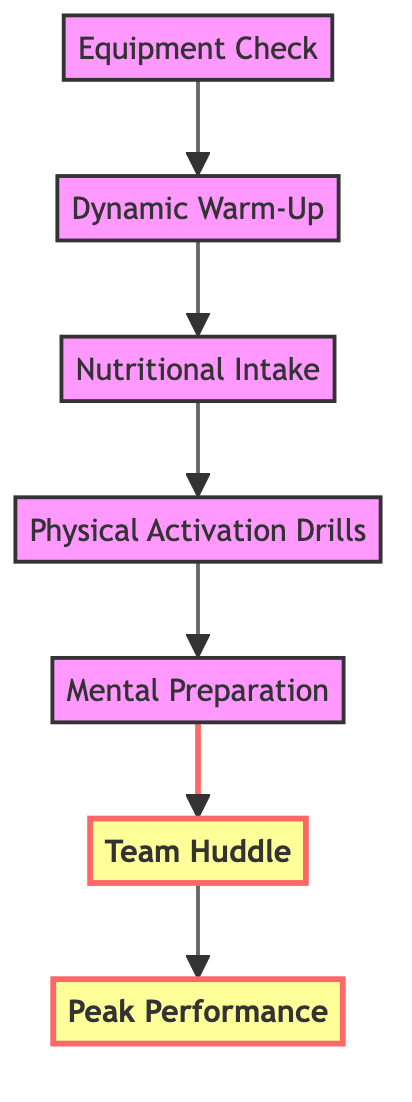What is the first step in the pre-game ritual? The first step listed in the diagram is "Equipment Check", which is positioned at the bottom as the starting point of the flow.
Answer: Equipment Check How many steps are there leading to peak performance? By counting the steps in the flow, there are six steps listed from "Equipment Check" to "Team Huddle", plus the final outcome "Peak Performance".
Answer: Six steps What comes directly after "Dynamic Warm-Up"? The node directly above "Dynamic Warm-Up" is "Nutritional Intake", indicating that this is the subsequent step after completing the warm-up.
Answer: Nutritional Intake Which step emphasizes team interaction? The "Team Huddle" step specifically mentions gathering with teammates, indicating a focus on team interaction and unity.
Answer: Team Huddle What is the last action before achieving peak performance? The last action in the flow before reaching "Peak Performance" is "Team Huddle". It serves as a collective motivation and strategy alignment moment before the game.
Answer: Team Huddle List the two highlighted elements in the diagram. The two highlighted elements that indicate important steps are "Team Huddle" and "Peak Performance". The highlight style emphasizes their significance within the flow.
Answer: Team Huddle, Peak Performance What is the main purpose of the "Mental Preparation" step? "Mental Preparation" focuses on building confidence and mental readiness through strategies like visualization and positive self-talk, preparing the athlete mentally for peak performance.
Answer: Building confidence and mental readiness Which step comes before "Physical Activation Drills"? The step directly before "Physical Activation Drills" in the diagram is "Nutritional Intake", which must be completed first to ensure proper energy levels.
Answer: Nutritional Intake 